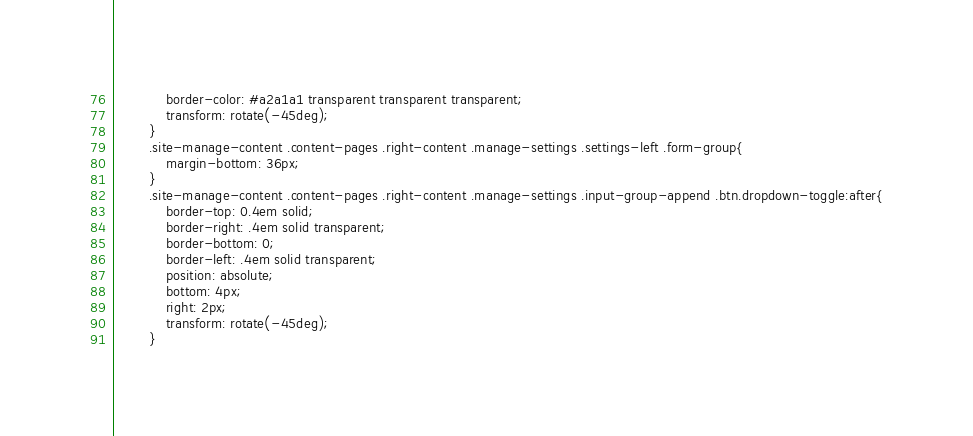Convert code to text. <code><loc_0><loc_0><loc_500><loc_500><_PHP_>            border-color: #a2a1a1 transparent transparent transparent;
            transform: rotate(-45deg);
        }
        .site-manage-content .content-pages .right-content .manage-settings .settings-left .form-group{
            margin-bottom: 36px;
        }
        .site-manage-content .content-pages .right-content .manage-settings .input-group-append .btn.dropdown-toggle:after{
            border-top: 0.4em solid;
            border-right: .4em solid transparent;
            border-bottom: 0;
            border-left: .4em solid transparent;
            position: absolute;
            bottom: 4px;
            right: 2px;
            transform: rotate(-45deg);
        }</code> 